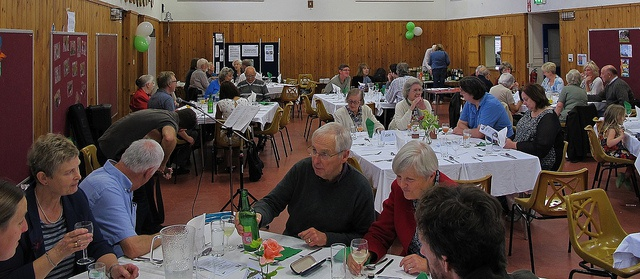Describe the objects in this image and their specific colors. I can see people in olive, black, gray, darkgray, and maroon tones, people in olive, black, brown, gray, and maroon tones, people in olive, black, brown, and maroon tones, people in olive, black, maroon, and brown tones, and people in olive, black, maroon, and gray tones in this image. 